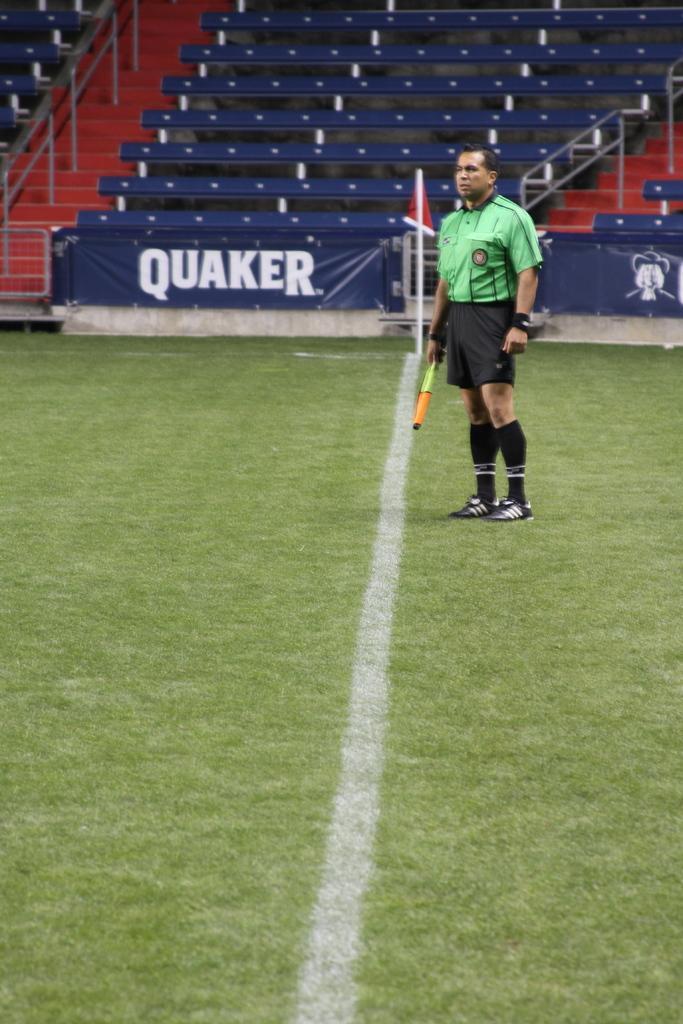How would you summarize this image in a sentence or two? In this image there is a person standing and holding an object, and at the background there are banners, benches, staircase, iron rods, a flag with a pole. 